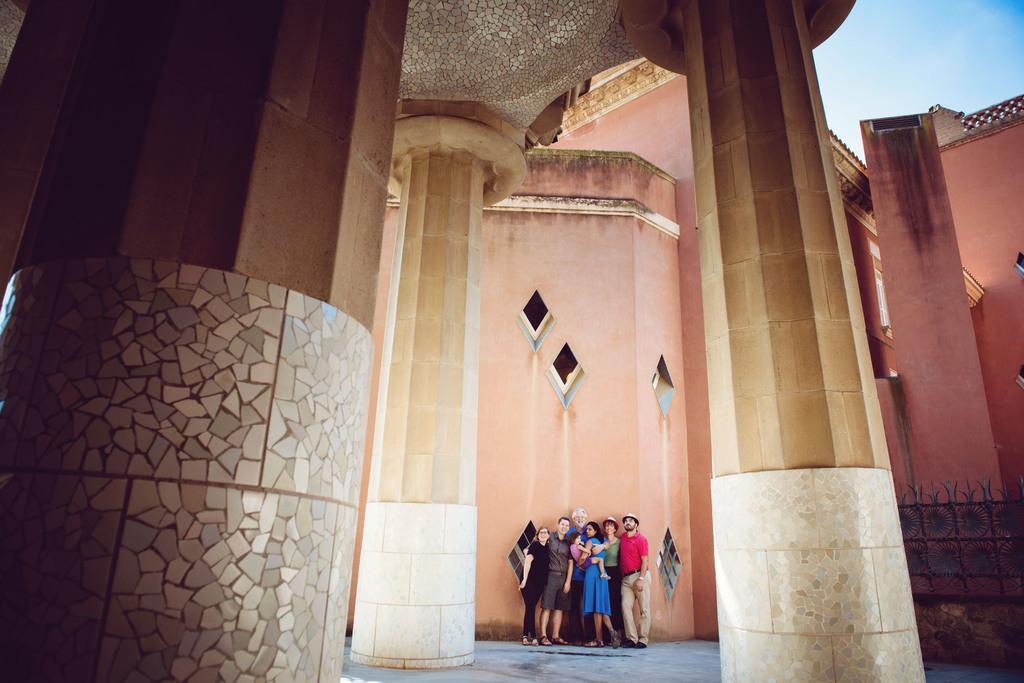How would you summarize this image in a sentence or two? There are group of persons in different color dresses, standing, near a wall of the building. In front of them, there are pillars. In the background, there are clouds in the blue sky. 